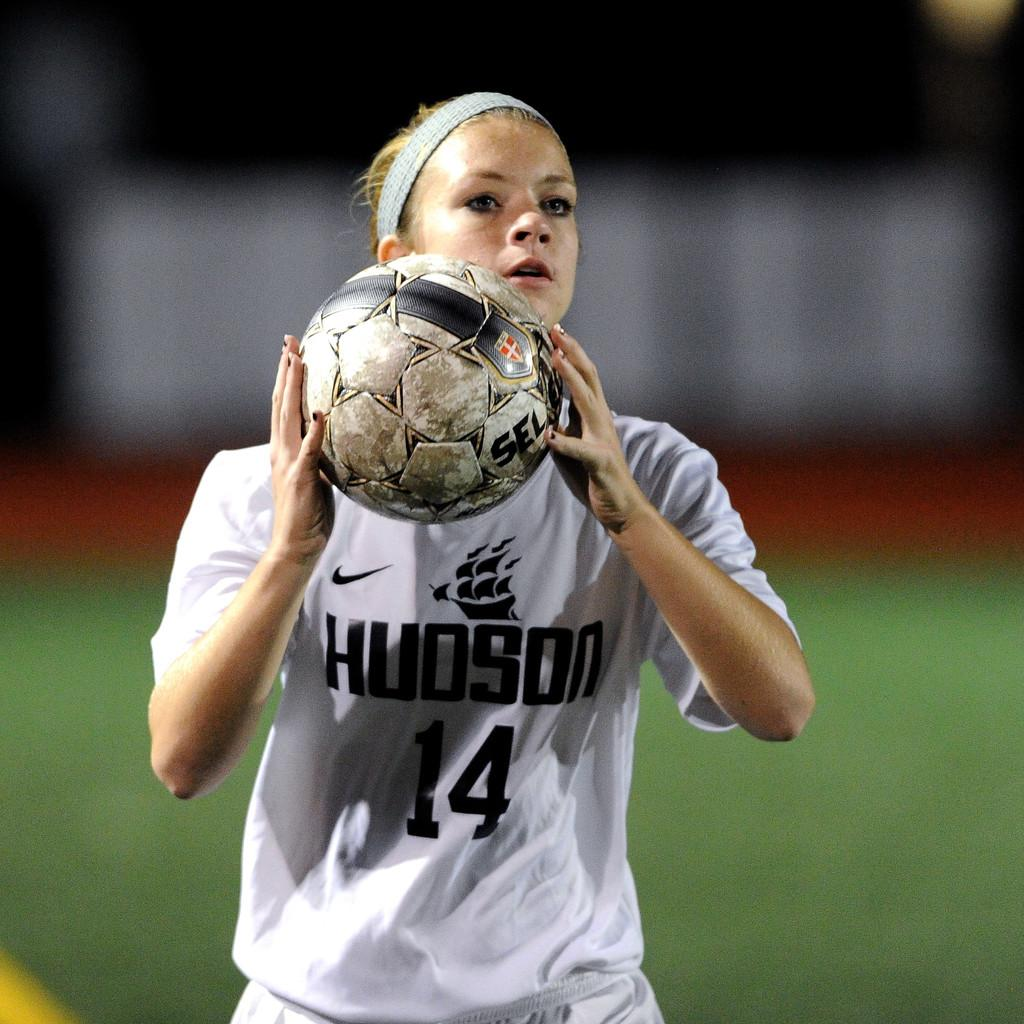<image>
Write a terse but informative summary of the picture. a person in a Hudson number 14 jersey about to throw a ball 